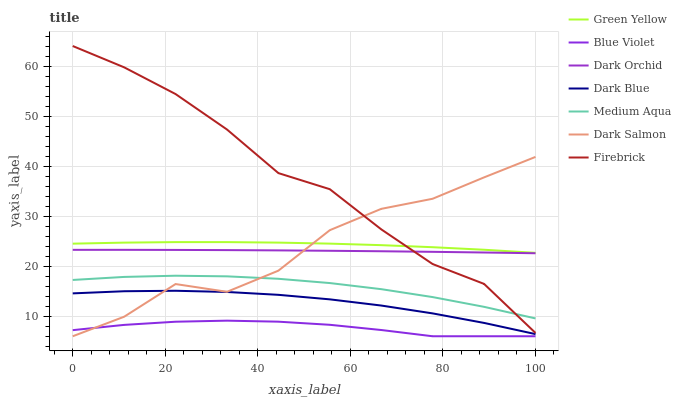Does Dark Salmon have the minimum area under the curve?
Answer yes or no. No. Does Dark Salmon have the maximum area under the curve?
Answer yes or no. No. Is Dark Salmon the smoothest?
Answer yes or no. No. Is Dark Orchid the roughest?
Answer yes or no. No. Does Dark Orchid have the lowest value?
Answer yes or no. No. Does Dark Salmon have the highest value?
Answer yes or no. No. Is Dark Orchid less than Green Yellow?
Answer yes or no. Yes. Is Green Yellow greater than Dark Orchid?
Answer yes or no. Yes. Does Dark Orchid intersect Green Yellow?
Answer yes or no. No. 